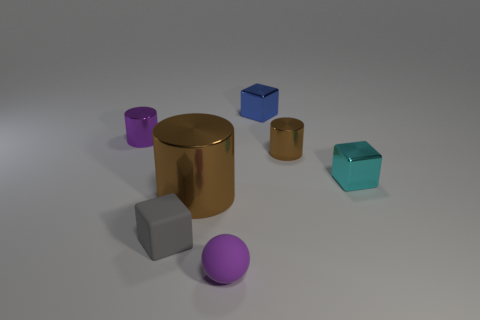Add 2 small cubes. How many objects exist? 9 Subtract all brown cylinders. How many cylinders are left? 1 Subtract 3 blocks. How many blocks are left? 0 Subtract all red cubes. How many brown cylinders are left? 2 Subtract all red objects. Subtract all big brown cylinders. How many objects are left? 6 Add 7 large brown objects. How many large brown objects are left? 8 Add 6 shiny cubes. How many shiny cubes exist? 8 Subtract all blue blocks. How many blocks are left? 2 Subtract 1 gray blocks. How many objects are left? 6 Subtract all balls. How many objects are left? 6 